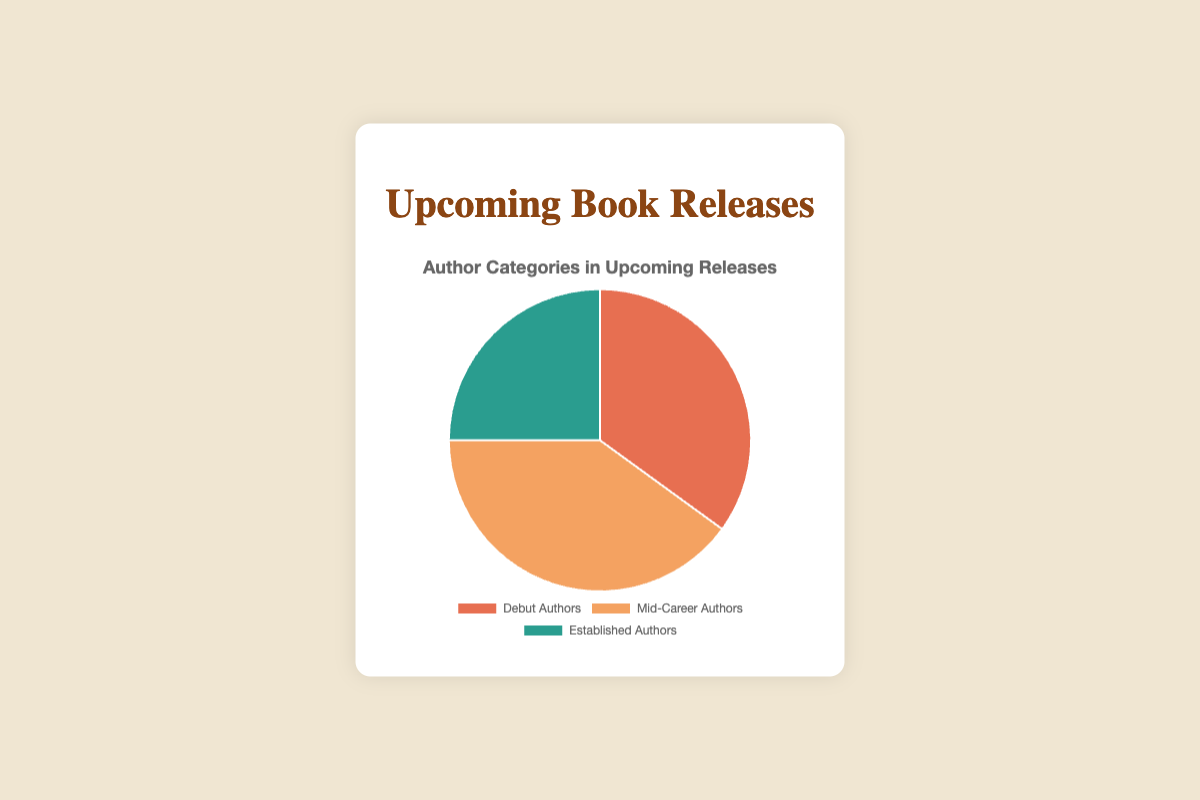What percentage of upcoming book releases are by debut authors? The figure shows the distribution of upcoming book releases among debut authors, mid-career authors, and established authors. The slice for debut authors is clearly labeled as 35%.
Answer: 35% Which category has the largest proportion of upcoming book releases? By examining the sizes of the slices in the pie chart, it is evident that the mid-career authors' slice is the largest, indicating it has the highest percentage.
Answer: Mid-Career Authors What is the combined percentage of debut and established authors in upcoming book releases? The pie chart can be used to determine the combined percentage by adding the debut authors' percentage (35%) to the established authors' percentage (25%). So, the total is 35% + 25% = 60%.
Answer: 60% Is the percentage of mid-career authors greater than the combined percentage of debut and established authors? First, determine the combined percentage of debut and established authors, which is 35% + 25% = 60%. Then, compare this to the percentage of mid-career authors, which is 40%. Since 60% is greater than 40%, the mid-career authors' percentage is not greater.
Answer: No What is the difference in percentage points between debut authors and established authors? Look at the percentages for debut authors (35%) and established authors (25%) in the chart. Subtract the percentage of established authors from the percentage of debut authors: 35% - 25% = 10%.
Answer: 10% Which slice is represented by the orange color in the pie chart? The pie chart segments are differentiated by color. The orange slice corresponds to the label for mid-career authors.
Answer: Mid-Career Authors How much smaller is the established authors' percentage compared to the mid-career authors' percentage? Identify the percentages of mid-career (40%) and established authors (25%) from the chart. Subtract the established authors' percentage from the mid-career authors' percentage: 40% - 25% = 15%.
Answer: 15% What is the average percentage of upcoming book releases across all three author categories? Add up the percentages for all three categories (35% + 40% + 25% = 100%). Then, divide by the number of categories, which is 3. The average is 100% / 3 ≈ 33.33%.
Answer: 33.33% How does the percentage of debut authors compare visually to the percentage of established authors? Visually, the pie chart segments show that the debut authors' segment is larger than the established authors' segment, indicating a higher percentage for debut authors compared to established authors.
Answer: Larger 